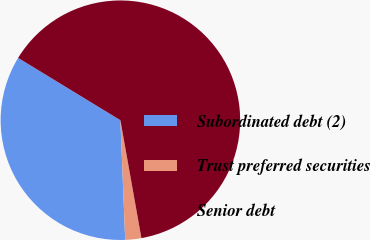<chart> <loc_0><loc_0><loc_500><loc_500><pie_chart><fcel>Subordinated debt (2)<fcel>Trust preferred securities<fcel>Senior debt<nl><fcel>34.35%<fcel>2.17%<fcel>63.48%<nl></chart> 